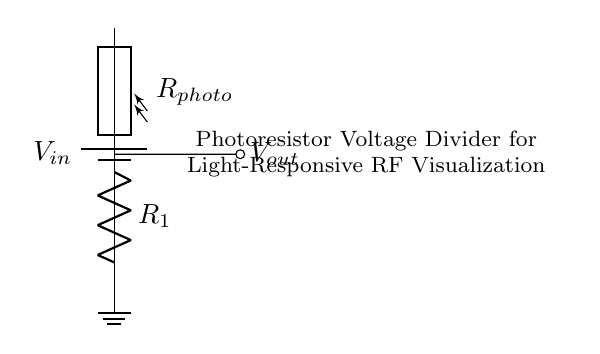What is the input voltage of this circuit? The input voltage is denoted as V_in in the circuit. In various implementations, it is typically represented as a certain value (like 5V).
Answer: V_in What components are used in this circuit? This circuit includes a photoresistor and a fixed resistor, denoted as R_photo and R_1 respectively. These components are essential to the voltage divider configuration.
Answer: Photoresistor and Fixed Resistor What is the role of the photoresistor in this circuit? The photoresistor's resistance changes with light intensity, allowing it to modulate the voltage output based on ambient light conditions. This is critical for the light-responsive nature of the circuit.
Answer: Modulate voltage based on light How does the output voltage relate to the input voltage in this divider? The output voltage V_out is derived from the voltage divider formula V_out = V_in * (R_1 / (R_1 + R_photo)). As R_photo changes with light, V_out also changes proportionally.
Answer: V_out = V_in * (R_1 / (R_1 + R_photo)) What happens to V_out when light intensity increases? As light intensity increases, the resistance of the photoresistor decreases, leading to a higher output voltage due to increased current flow through R_1 and a larger voltage drop across it.
Answer: V_out increases Which type of circuit is depicted in the diagram? The circuit type is a voltage divider, specifically using a photoresistor, as it divides the input voltage to provide a controlled output based on light conditions.
Answer: Voltage Divider 